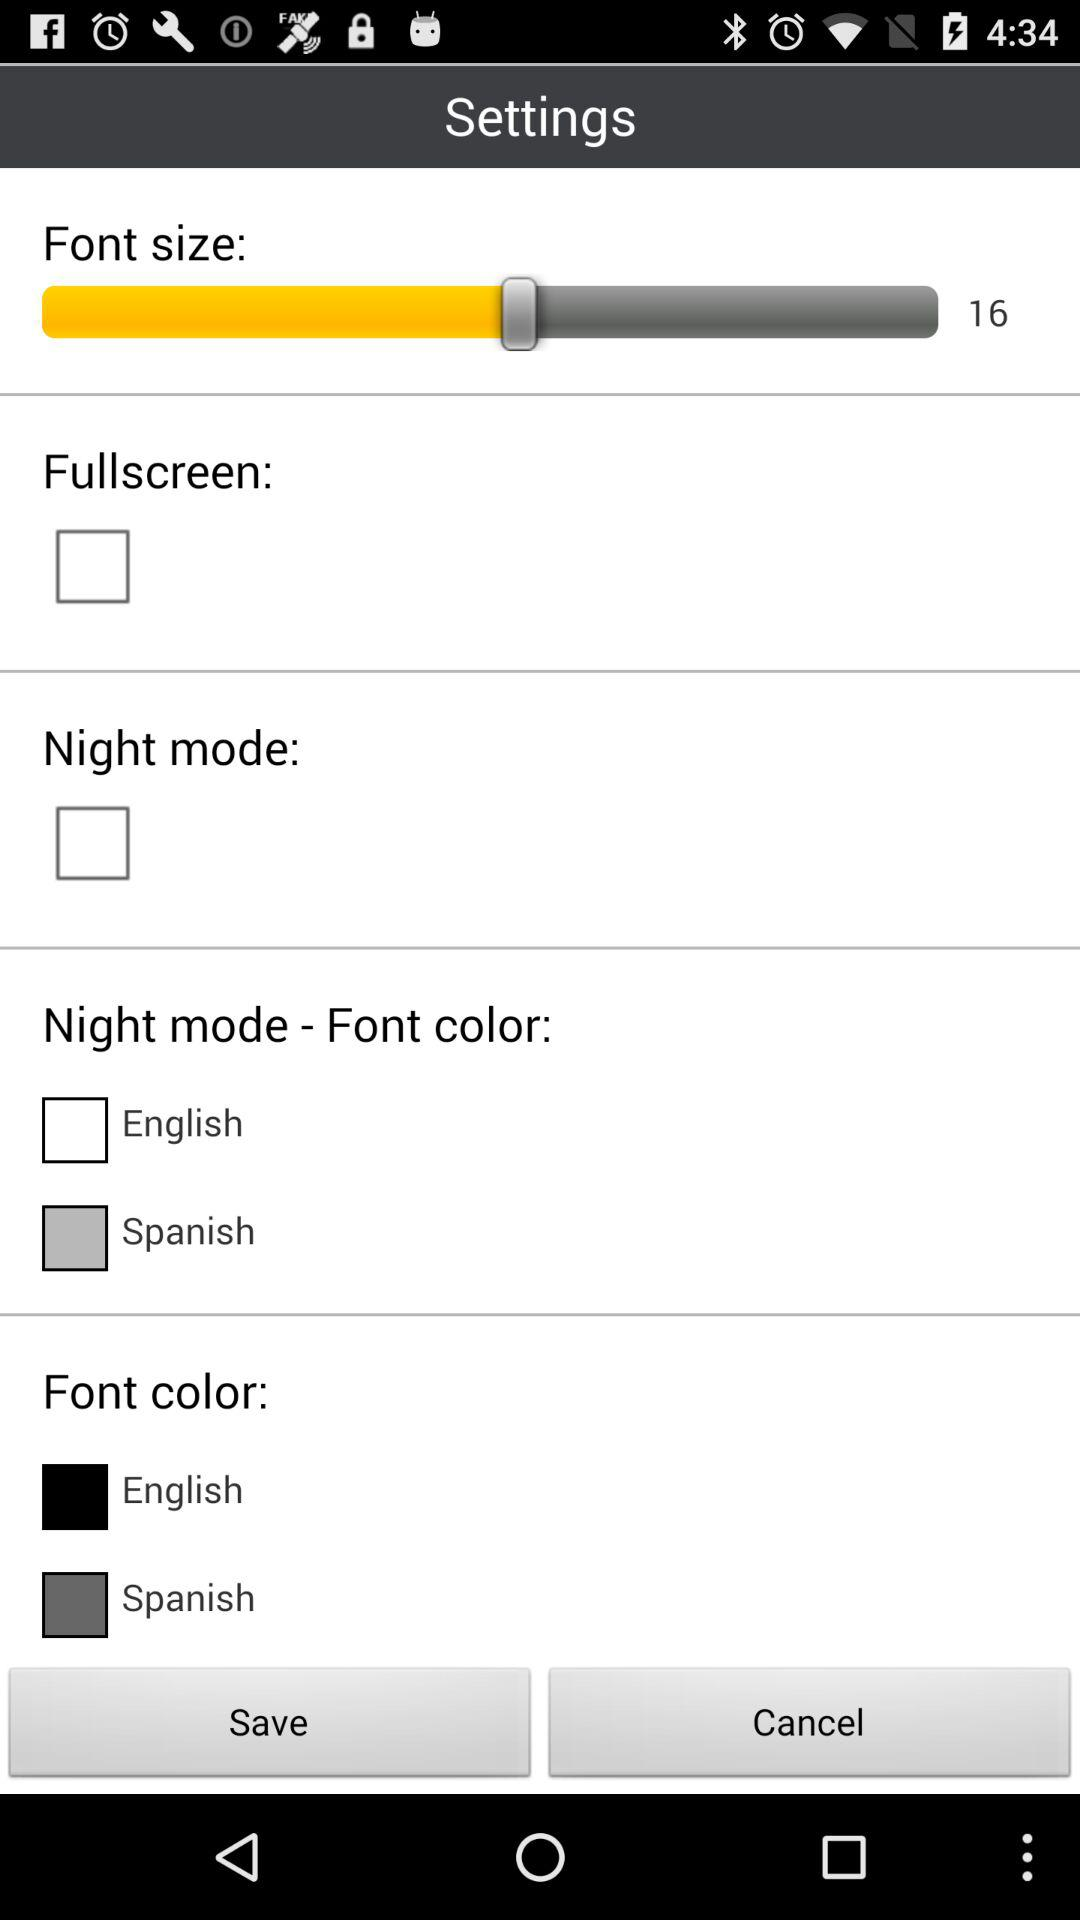What is the status of the "Fullscreen" setting? The status is "off". 